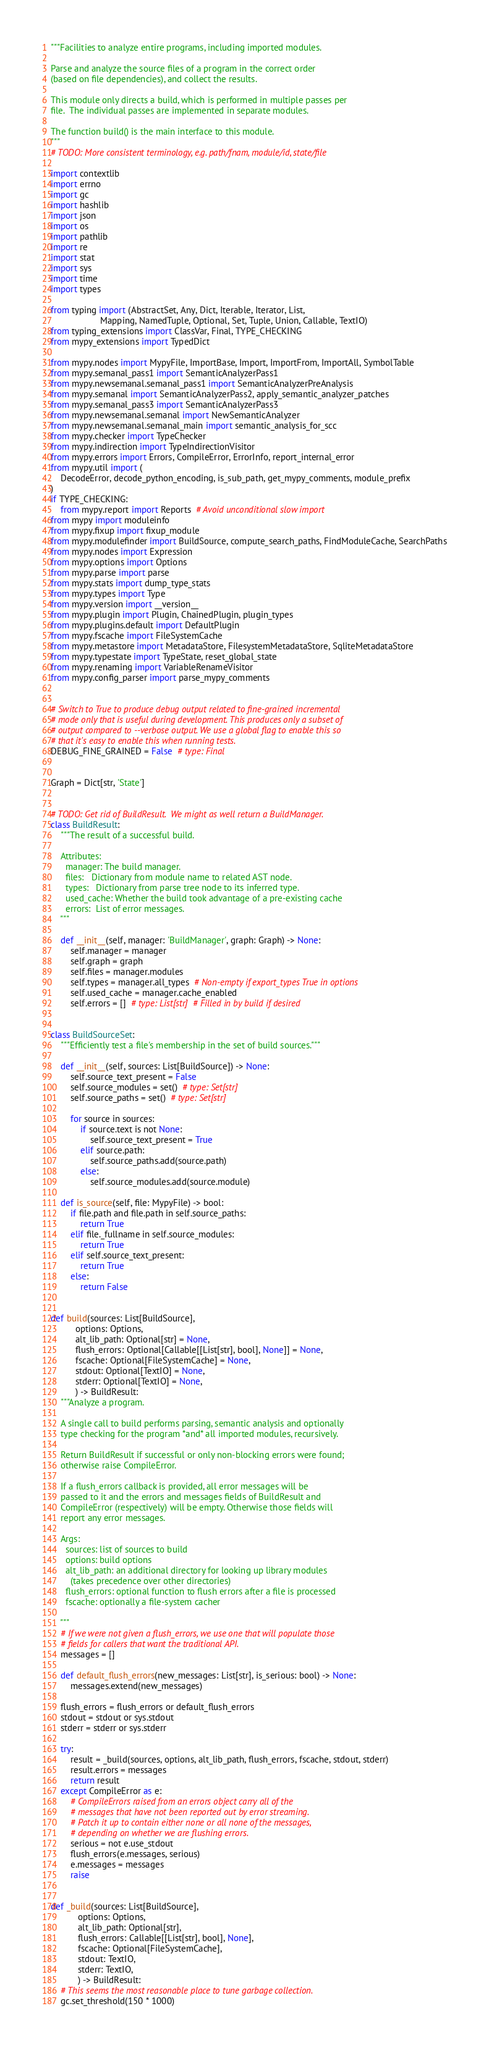Convert code to text. <code><loc_0><loc_0><loc_500><loc_500><_Python_>"""Facilities to analyze entire programs, including imported modules.

Parse and analyze the source files of a program in the correct order
(based on file dependencies), and collect the results.

This module only directs a build, which is performed in multiple passes per
file.  The individual passes are implemented in separate modules.

The function build() is the main interface to this module.
"""
# TODO: More consistent terminology, e.g. path/fnam, module/id, state/file

import contextlib
import errno
import gc
import hashlib
import json
import os
import pathlib
import re
import stat
import sys
import time
import types

from typing import (AbstractSet, Any, Dict, Iterable, Iterator, List,
                    Mapping, NamedTuple, Optional, Set, Tuple, Union, Callable, TextIO)
from typing_extensions import ClassVar, Final, TYPE_CHECKING
from mypy_extensions import TypedDict

from mypy.nodes import MypyFile, ImportBase, Import, ImportFrom, ImportAll, SymbolTable
from mypy.semanal_pass1 import SemanticAnalyzerPass1
from mypy.newsemanal.semanal_pass1 import SemanticAnalyzerPreAnalysis
from mypy.semanal import SemanticAnalyzerPass2, apply_semantic_analyzer_patches
from mypy.semanal_pass3 import SemanticAnalyzerPass3
from mypy.newsemanal.semanal import NewSemanticAnalyzer
from mypy.newsemanal.semanal_main import semantic_analysis_for_scc
from mypy.checker import TypeChecker
from mypy.indirection import TypeIndirectionVisitor
from mypy.errors import Errors, CompileError, ErrorInfo, report_internal_error
from mypy.util import (
    DecodeError, decode_python_encoding, is_sub_path, get_mypy_comments, module_prefix
)
if TYPE_CHECKING:
    from mypy.report import Reports  # Avoid unconditional slow import
from mypy import moduleinfo
from mypy.fixup import fixup_module
from mypy.modulefinder import BuildSource, compute_search_paths, FindModuleCache, SearchPaths
from mypy.nodes import Expression
from mypy.options import Options
from mypy.parse import parse
from mypy.stats import dump_type_stats
from mypy.types import Type
from mypy.version import __version__
from mypy.plugin import Plugin, ChainedPlugin, plugin_types
from mypy.plugins.default import DefaultPlugin
from mypy.fscache import FileSystemCache
from mypy.metastore import MetadataStore, FilesystemMetadataStore, SqliteMetadataStore
from mypy.typestate import TypeState, reset_global_state
from mypy.renaming import VariableRenameVisitor
from mypy.config_parser import parse_mypy_comments


# Switch to True to produce debug output related to fine-grained incremental
# mode only that is useful during development. This produces only a subset of
# output compared to --verbose output. We use a global flag to enable this so
# that it's easy to enable this when running tests.
DEBUG_FINE_GRAINED = False  # type: Final


Graph = Dict[str, 'State']


# TODO: Get rid of BuildResult.  We might as well return a BuildManager.
class BuildResult:
    """The result of a successful build.

    Attributes:
      manager: The build manager.
      files:   Dictionary from module name to related AST node.
      types:   Dictionary from parse tree node to its inferred type.
      used_cache: Whether the build took advantage of a pre-existing cache
      errors:  List of error messages.
    """

    def __init__(self, manager: 'BuildManager', graph: Graph) -> None:
        self.manager = manager
        self.graph = graph
        self.files = manager.modules
        self.types = manager.all_types  # Non-empty if export_types True in options
        self.used_cache = manager.cache_enabled
        self.errors = []  # type: List[str]  # Filled in by build if desired


class BuildSourceSet:
    """Efficiently test a file's membership in the set of build sources."""

    def __init__(self, sources: List[BuildSource]) -> None:
        self.source_text_present = False
        self.source_modules = set()  # type: Set[str]
        self.source_paths = set()  # type: Set[str]

        for source in sources:
            if source.text is not None:
                self.source_text_present = True
            elif source.path:
                self.source_paths.add(source.path)
            else:
                self.source_modules.add(source.module)

    def is_source(self, file: MypyFile) -> bool:
        if file.path and file.path in self.source_paths:
            return True
        elif file._fullname in self.source_modules:
            return True
        elif self.source_text_present:
            return True
        else:
            return False


def build(sources: List[BuildSource],
          options: Options,
          alt_lib_path: Optional[str] = None,
          flush_errors: Optional[Callable[[List[str], bool], None]] = None,
          fscache: Optional[FileSystemCache] = None,
          stdout: Optional[TextIO] = None,
          stderr: Optional[TextIO] = None,
          ) -> BuildResult:
    """Analyze a program.

    A single call to build performs parsing, semantic analysis and optionally
    type checking for the program *and* all imported modules, recursively.

    Return BuildResult if successful or only non-blocking errors were found;
    otherwise raise CompileError.

    If a flush_errors callback is provided, all error messages will be
    passed to it and the errors and messages fields of BuildResult and
    CompileError (respectively) will be empty. Otherwise those fields will
    report any error messages.

    Args:
      sources: list of sources to build
      options: build options
      alt_lib_path: an additional directory for looking up library modules
        (takes precedence over other directories)
      flush_errors: optional function to flush errors after a file is processed
      fscache: optionally a file-system cacher

    """
    # If we were not given a flush_errors, we use one that will populate those
    # fields for callers that want the traditional API.
    messages = []

    def default_flush_errors(new_messages: List[str], is_serious: bool) -> None:
        messages.extend(new_messages)

    flush_errors = flush_errors or default_flush_errors
    stdout = stdout or sys.stdout
    stderr = stderr or sys.stderr

    try:
        result = _build(sources, options, alt_lib_path, flush_errors, fscache, stdout, stderr)
        result.errors = messages
        return result
    except CompileError as e:
        # CompileErrors raised from an errors object carry all of the
        # messages that have not been reported out by error streaming.
        # Patch it up to contain either none or all none of the messages,
        # depending on whether we are flushing errors.
        serious = not e.use_stdout
        flush_errors(e.messages, serious)
        e.messages = messages
        raise


def _build(sources: List[BuildSource],
           options: Options,
           alt_lib_path: Optional[str],
           flush_errors: Callable[[List[str], bool], None],
           fscache: Optional[FileSystemCache],
           stdout: TextIO,
           stderr: TextIO,
           ) -> BuildResult:
    # This seems the most reasonable place to tune garbage collection.
    gc.set_threshold(150 * 1000)
</code> 